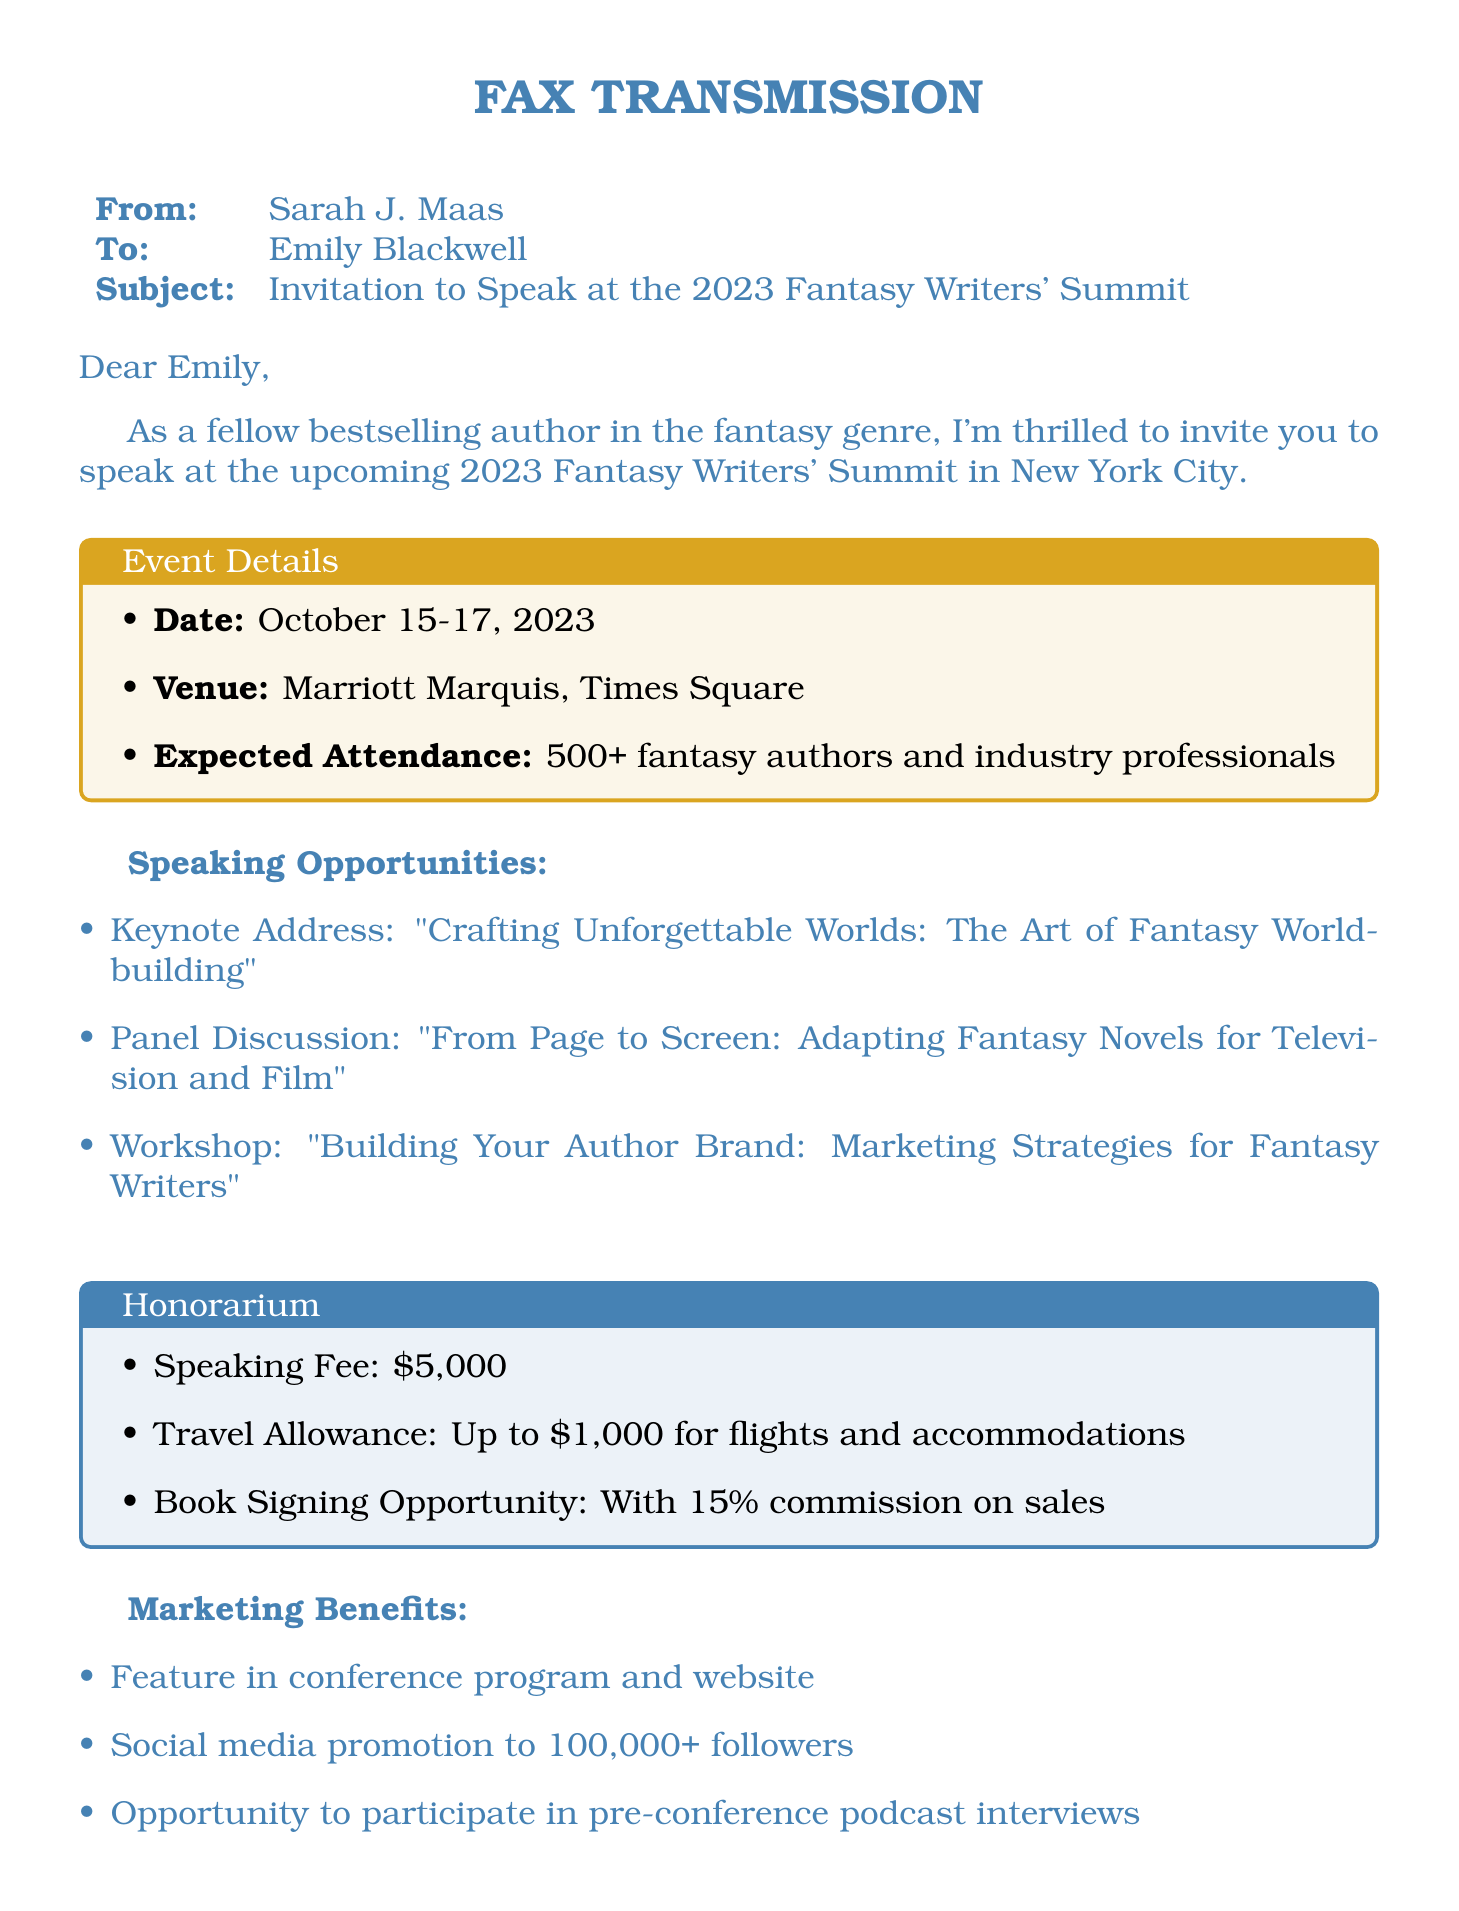What is the date of the event? The date of the event is specified in the document as October 15-17, 2023.
Answer: October 15-17, 2023 What is the venue for the conference? The venue for the conference is the Marriott Marquis, Times Square, as mentioned in the document.
Answer: Marriott Marquis, Times Square What is the expected attendance? The expected attendance is given as 500+ fantasy authors and industry professionals.
Answer: 500+ What is the speaking fee for the event? The speaking fee is listed as $5,000 in the honorarium section of the document.
Answer: $5,000 What is the travel allowance for speakers? The travel allowance is specified as up to $1,000 for flights and accommodations.
Answer: Up to $1,000 What is one of the panel discussion topics? One of the panel discussion topics is "From Page to Screen: Adapting Fantasy Novels for Television and Film."
Answer: From Page to Screen: Adapting Fantasy Novels for Television and Film What marketing benefits are offered? The document mentions features in the conference program and website as one of the marketing benefits.
Answer: Feature in conference program and website Who is the sender of the fax? The sender of the fax is identified as Sarah J. Maas in the document.
Answer: Sarah J. Maas What is the commission rate for book signing sales? The commission rate for book signing sales is stated as 15% in the honorarium section.
Answer: 15% 